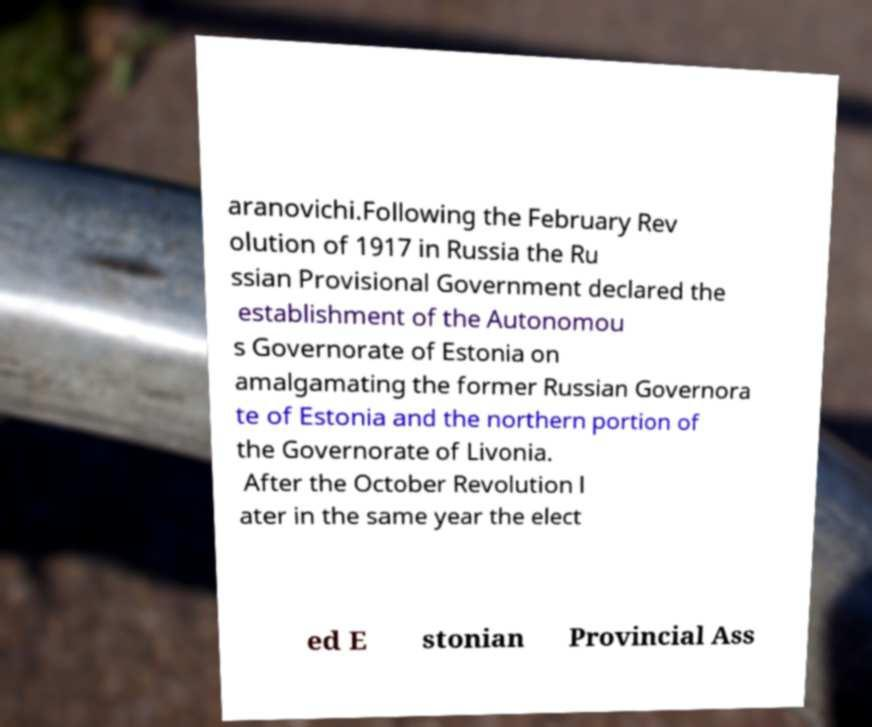Could you assist in decoding the text presented in this image and type it out clearly? aranovichi.Following the February Rev olution of 1917 in Russia the Ru ssian Provisional Government declared the establishment of the Autonomou s Governorate of Estonia on amalgamating the former Russian Governora te of Estonia and the northern portion of the Governorate of Livonia. After the October Revolution l ater in the same year the elect ed E stonian Provincial Ass 